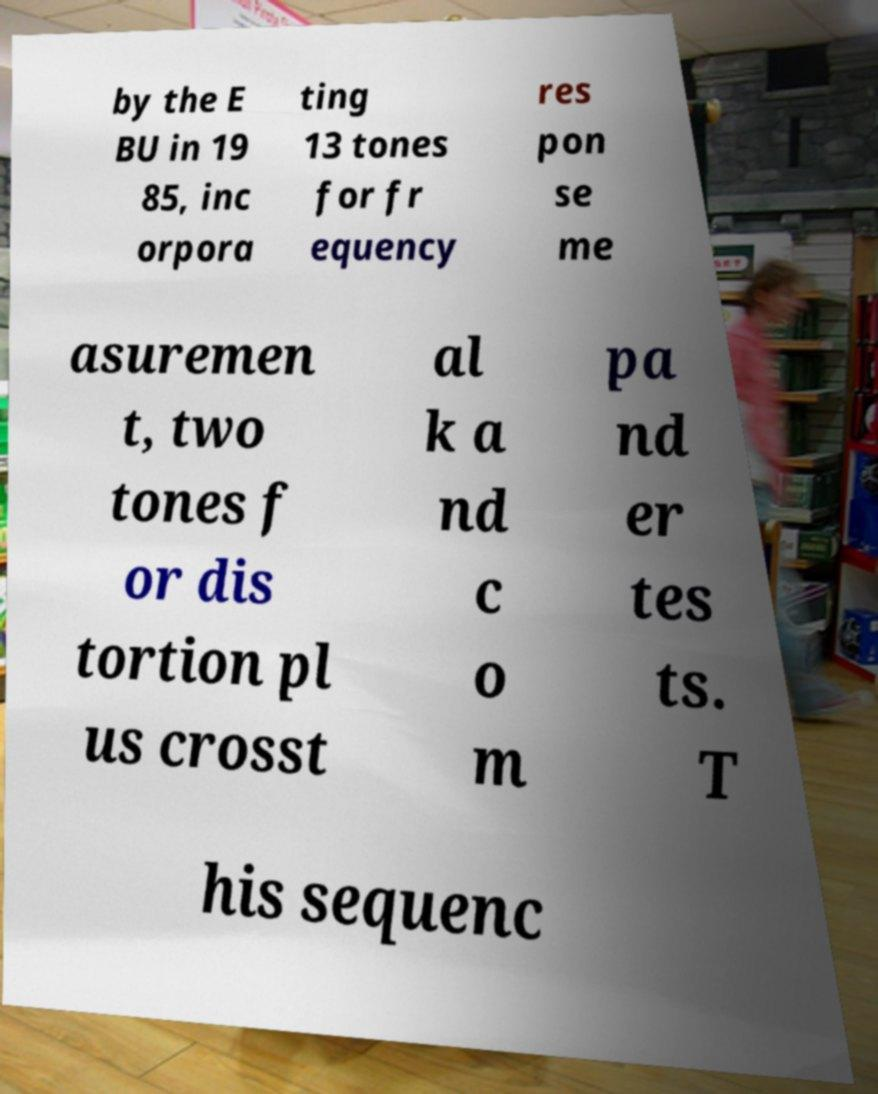Please read and relay the text visible in this image. What does it say? by the E BU in 19 85, inc orpora ting 13 tones for fr equency res pon se me asuremen t, two tones f or dis tortion pl us crosst al k a nd c o m pa nd er tes ts. T his sequenc 